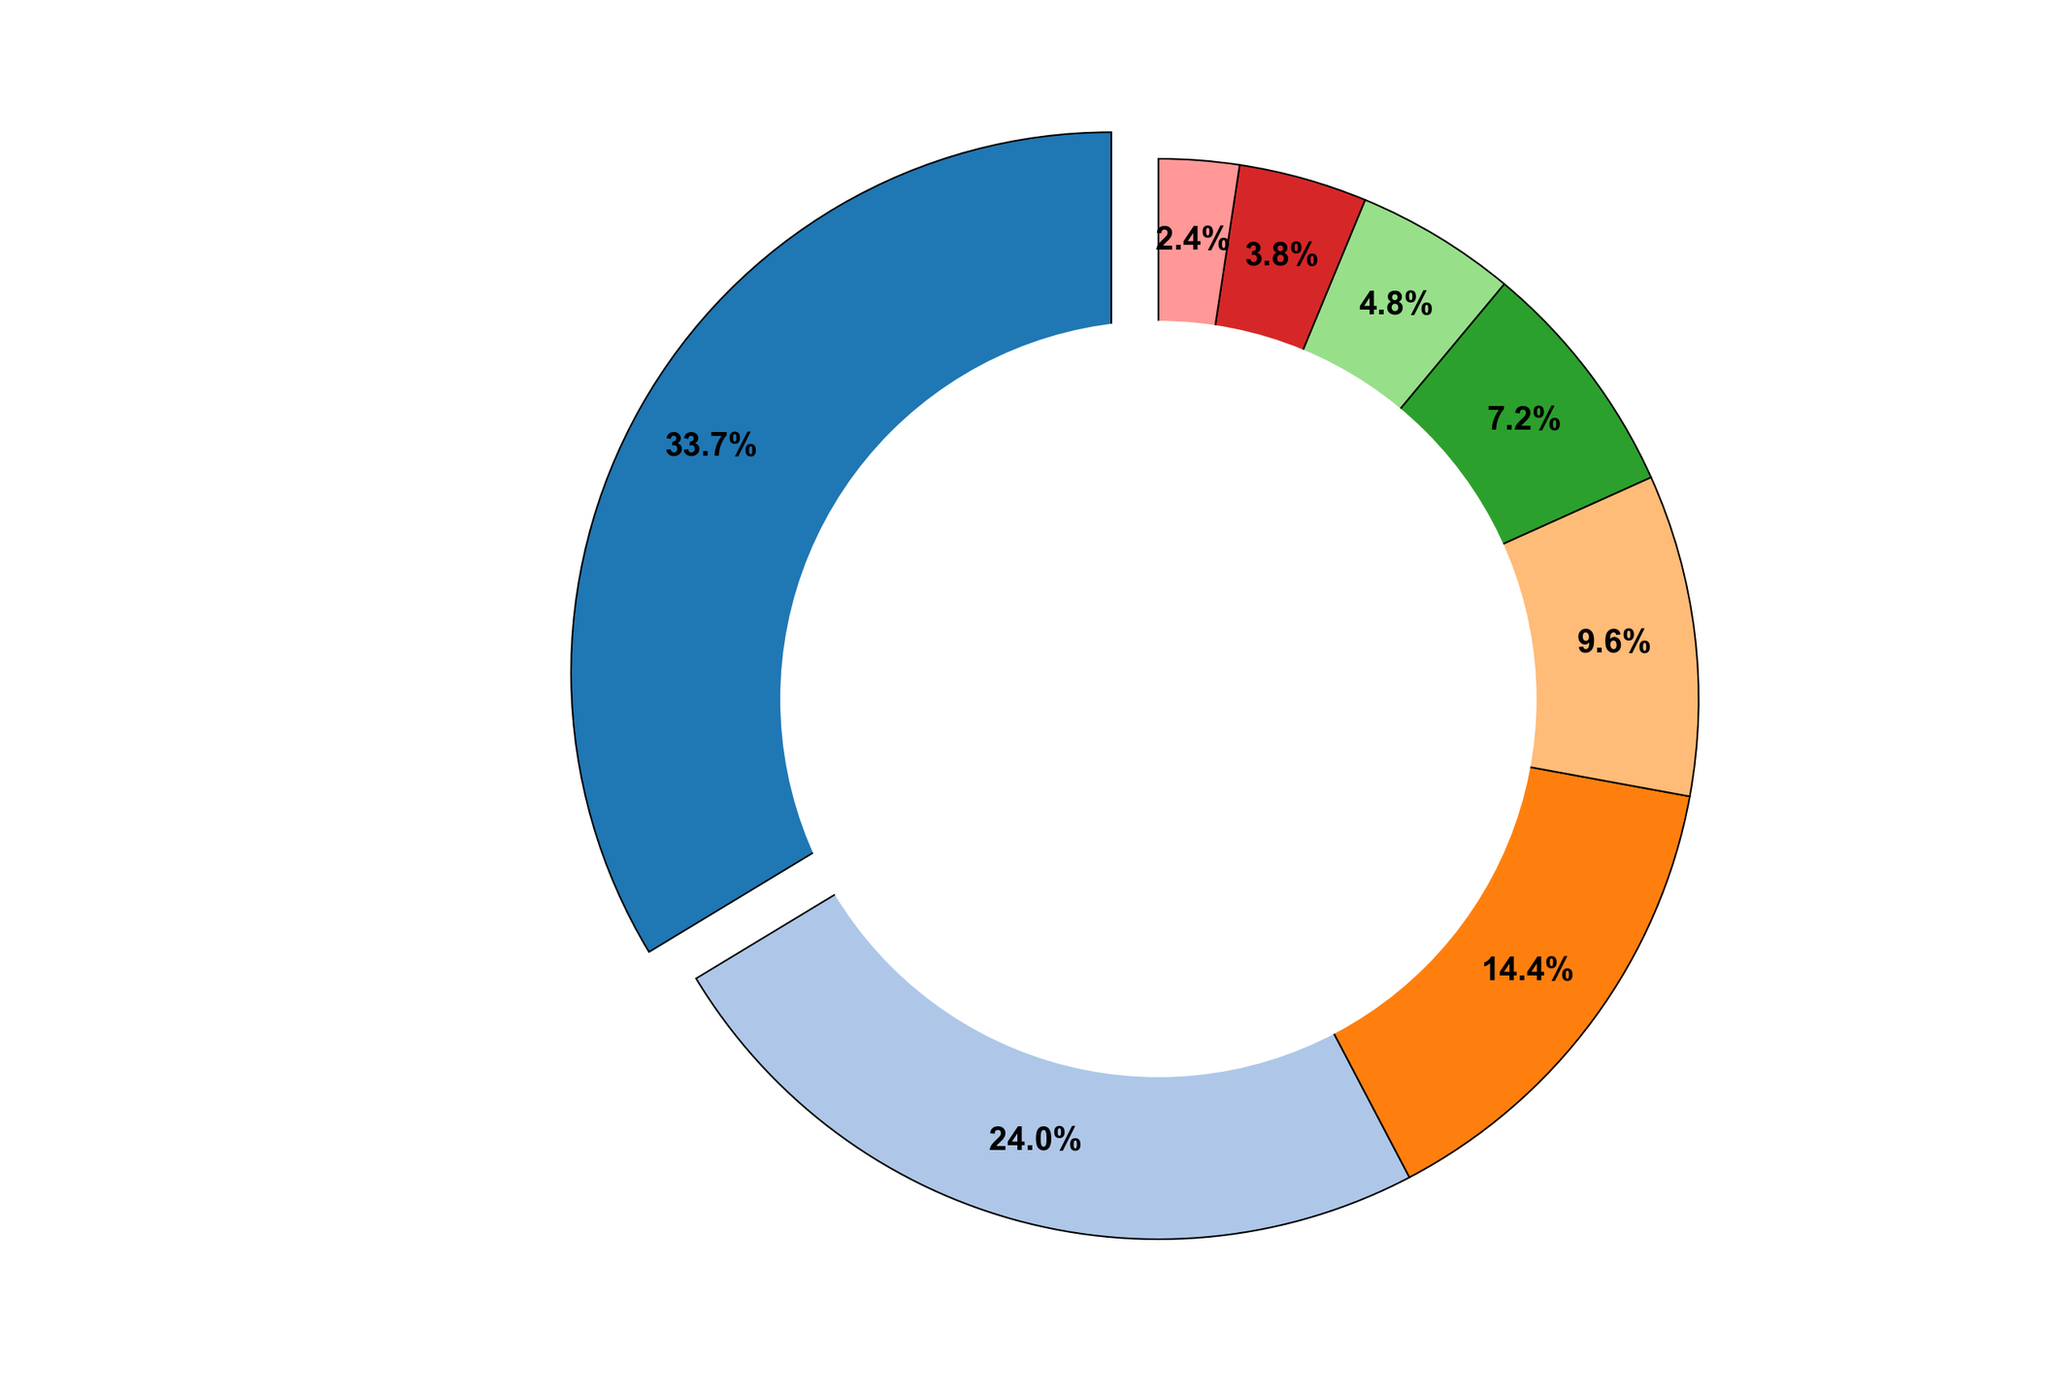What's the percentage of the total funding that goes to Autonomous Vehicle Technology and Medical Robotics combined? To find the combined percentage, sum the funding amounts for Autonomous Vehicle Technology and Medical Robotics (700 + 500 = 1200) and then divide this by the total funding (700 + 500 + 300 + 200 + 150 + 100 + 80 + 50 = 2080). The combined funding is 1200/2080 = 0.5769, which is approximately 57.7%.
Answer: 57.7% Which category has the least funding, and what is the percentage of total funding for this category? First, identify the category with the least funding, which is Entertainment Robotics at 50 million USD. The percentage of total funding is calculated by dividing the funding for Entertainment Robotics by the total funding (50/2080 = 0.024), which is approximately 2.4%.
Answer: Entertainment Robotics, 2.4% Is the funding for Agricultural Robotics greater than the combined funding for Space Robotics and Search and Rescue Robotics? Compare the funding amounts: Agricultural Robotics has 100 million USD, while the combined funding for Space Robotics and Search and Rescue Robotics is 200 + 80 = 280 million USD. Since 100 < 280, Agricultural Robotics has less funding.
Answer: No What is the combined percentage of funding for Industrial Robotics, Space Robotics, and Personal Robotics? Sum the funding amounts for the three categories (300 + 200 + 150 = 650). Next, divide by the total funding (650/2080 = 0.3125), which is approximately 31.3%.
Answer: 31.3% Which categories have a funding percentage greater than 10%, and what are their corresponding percentages? Identify categories with funding more than 10% of total funding. The categories and their percentages are:
- Autonomous Vehicle Technology: 700/2080 ≈ 33.7%
- Medical Robotics: 500/2080 ≈ 24.0%
- Industrial Robotics: 300/2080 ≈ 14.4%
These three categories have percentages greater than 10%.
Answer: Autonomous Vehicle Technology: 33.7%, Medical Robotics: 24.0%, Industrial Robotics: 14.4% How does the funding for Personal Robotics compare to that for Medical Robotics in terms of percentage? Calculate the funding percentages for both categories: Personal Robotics: 150/2080 ≈ 7.2%, Medical Robotics: 500/2080 ≈ 24.0%. Medical Robotics has a significantly higher percentage than Personal Robotics.
Answer: Medical Robotics is 16.8% higher If the funding for Autonomous Vehicle Technology was distributed equally among all categories, how much would each category receive? Divide the funding for Autonomous Vehicle Technology by the number of categories (700 million USD / 8 categories = 87.5 million USD). Each category would receive an additional 87.5 million USD.
Answer: 87.5 million USD Which category has the third highest funding, and how much is it? Identify the top three categories by funding:
1. Autonomous Vehicle Technology: 700 million USD
2. Medical Robotics: 500 million USD
3. Industrial Robotics: 300 million USD
Thus, Industrial Robotics has the third highest funding with 300 million USD.
Answer: Industrial Robotics, 300 million USD 